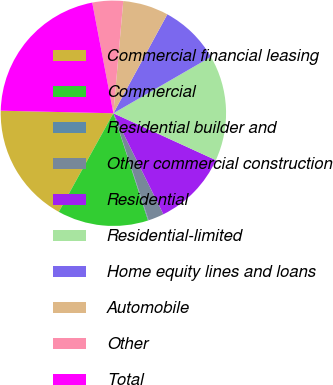<chart> <loc_0><loc_0><loc_500><loc_500><pie_chart><fcel>Commercial financial leasing<fcel>Commercial<fcel>Residential builder and<fcel>Other commercial construction<fcel>Residential<fcel>Residential-limited<fcel>Home equity lines and loans<fcel>Automobile<fcel>Other<fcel>Total<nl><fcel>17.32%<fcel>13.02%<fcel>0.09%<fcel>2.25%<fcel>10.86%<fcel>15.17%<fcel>8.71%<fcel>6.55%<fcel>4.4%<fcel>21.63%<nl></chart> 